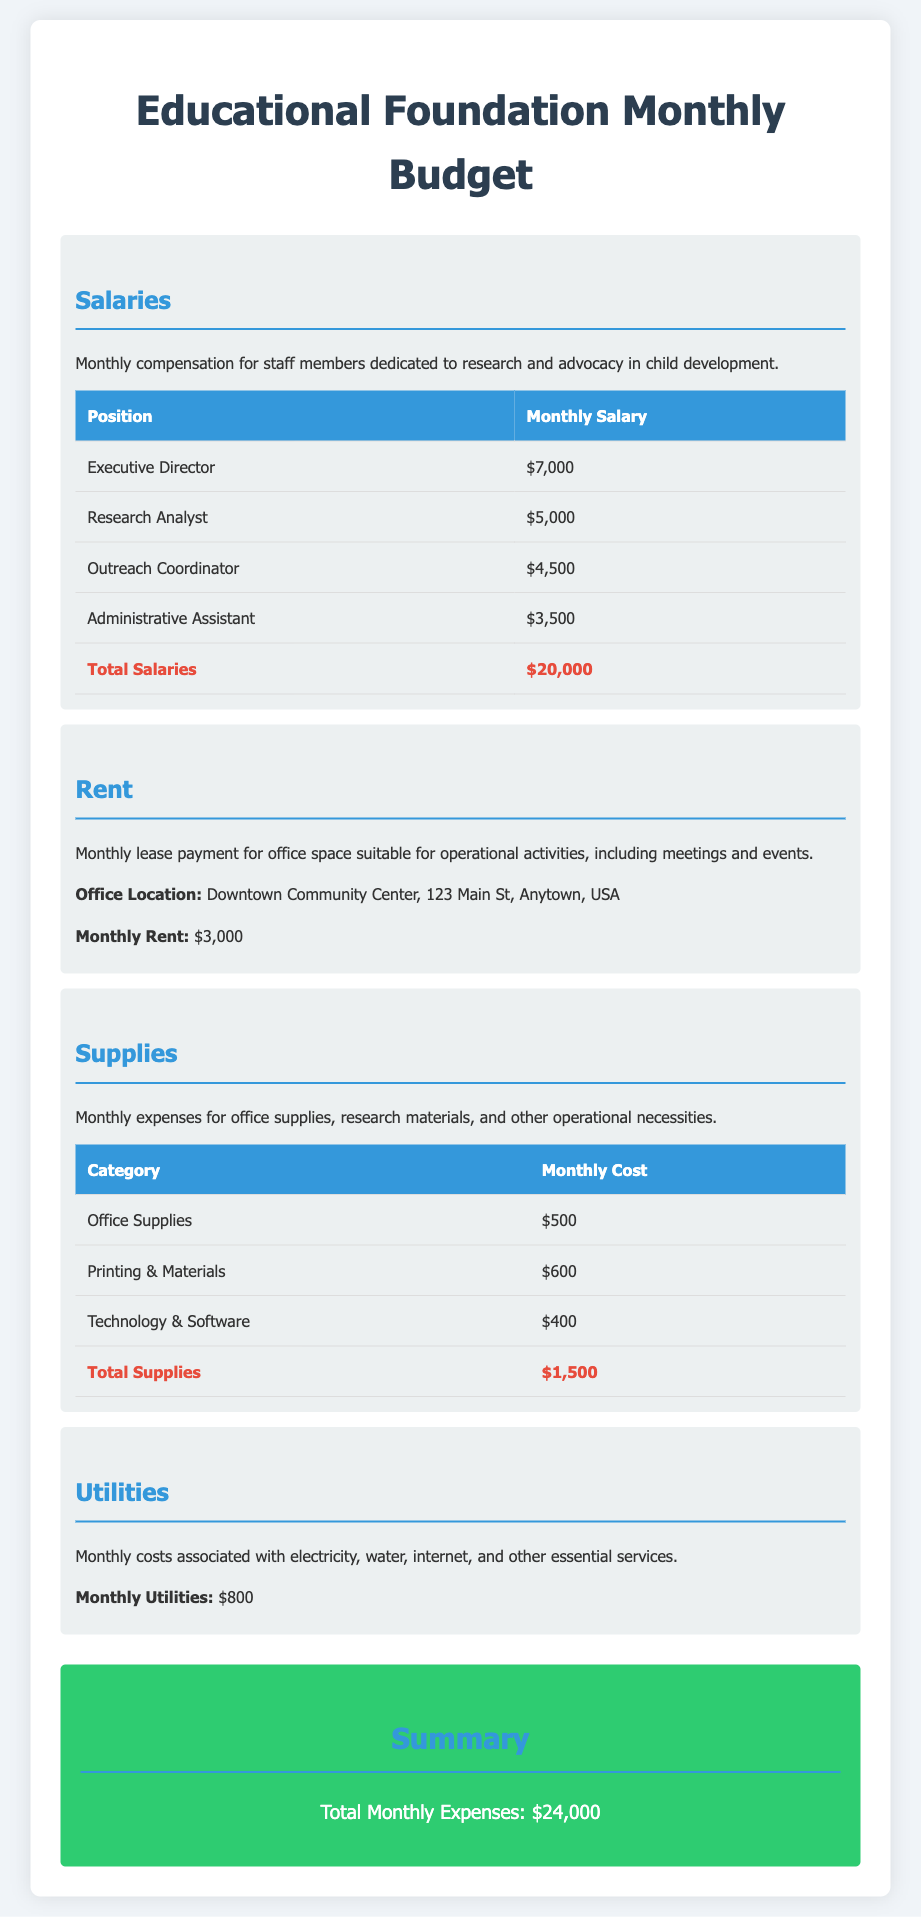what is the total salary expense? The total salary expense is calculated from the individual salaries listed for each position, which adds up to $20,000.
Answer: $20,000 what is the monthly rent for the office? The monthly rent is explicitly stated in the document as the cost for leasing the office space.
Answer: $3,000 how much is allocated for printing and materials? The document specifies the cost for printing and materials within the supplies section, providing a specific dollar amount.
Answer: $600 what is the monthly expense for utilities? The document lists the monthly utilities cost separately, which is clearly stated.
Answer: $800 who is the Outreach Coordinator? The document lists the Outreach Coordinator as one of the positions under salaries, providing their title and salary.
Answer: Outreach Coordinator what is the total monthly expense for supplies? Total supplies are calculated based on individual expenses for various categories, culminating in a total figure found in the document.
Answer: $1,500 where is the office located? The document provides the full address of the office location within the rent section.
Answer: Downtown Community Center, 123 Main St, Anytown, USA what is the total monthly operational expense? The total monthly operational expenses are summarized at the end of the document, combining all expenses from different sections.
Answer: $24,000 how many staff members are listed in the salaries section? The number of staff members is determined by counting the positions listed under the salaries section in the document.
Answer: 4 